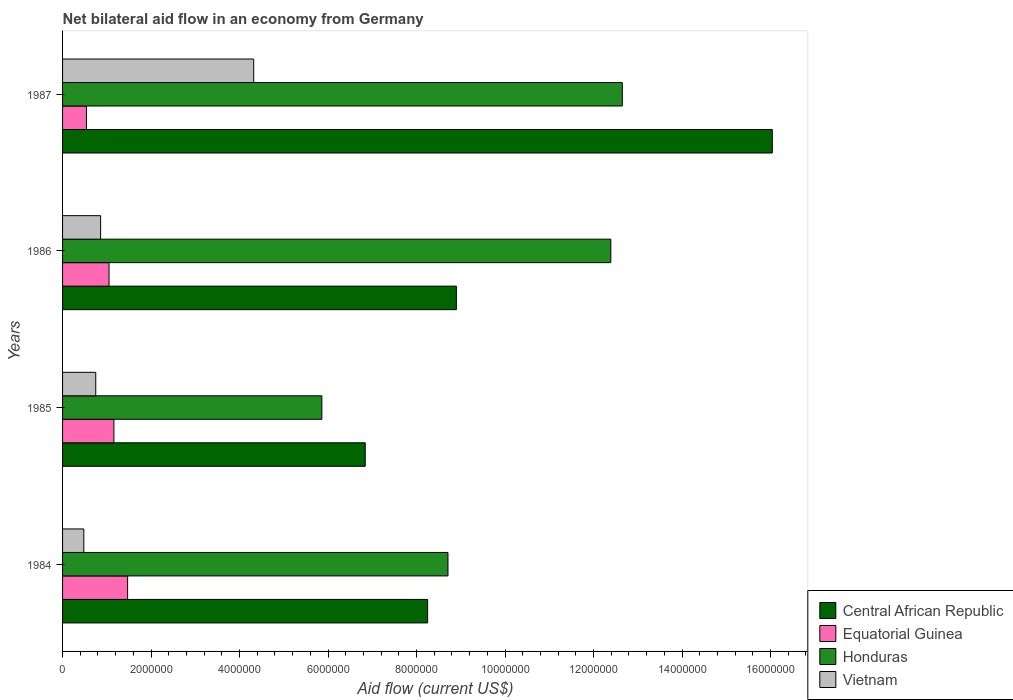How many different coloured bars are there?
Your answer should be very brief. 4. How many bars are there on the 4th tick from the bottom?
Make the answer very short. 4. What is the label of the 3rd group of bars from the top?
Offer a terse response. 1985. In how many cases, is the number of bars for a given year not equal to the number of legend labels?
Keep it short and to the point. 0. What is the net bilateral aid flow in Central African Republic in 1985?
Ensure brevity in your answer.  6.84e+06. Across all years, what is the maximum net bilateral aid flow in Central African Republic?
Offer a very short reply. 1.60e+07. Across all years, what is the minimum net bilateral aid flow in Central African Republic?
Give a very brief answer. 6.84e+06. What is the total net bilateral aid flow in Honduras in the graph?
Offer a terse response. 3.96e+07. What is the difference between the net bilateral aid flow in Central African Republic in 1984 and that in 1987?
Offer a terse response. -7.79e+06. What is the difference between the net bilateral aid flow in Honduras in 1987 and the net bilateral aid flow in Equatorial Guinea in 1986?
Give a very brief answer. 1.16e+07. What is the average net bilateral aid flow in Honduras per year?
Your response must be concise. 9.90e+06. In the year 1986, what is the difference between the net bilateral aid flow in Central African Republic and net bilateral aid flow in Equatorial Guinea?
Your answer should be compact. 7.85e+06. What is the ratio of the net bilateral aid flow in Honduras in 1984 to that in 1987?
Ensure brevity in your answer.  0.69. Is the net bilateral aid flow in Equatorial Guinea in 1985 less than that in 1987?
Provide a short and direct response. No. Is the difference between the net bilateral aid flow in Central African Republic in 1986 and 1987 greater than the difference between the net bilateral aid flow in Equatorial Guinea in 1986 and 1987?
Provide a succinct answer. No. What is the difference between the highest and the second highest net bilateral aid flow in Honduras?
Provide a succinct answer. 2.60e+05. What is the difference between the highest and the lowest net bilateral aid flow in Equatorial Guinea?
Offer a very short reply. 9.30e+05. In how many years, is the net bilateral aid flow in Central African Republic greater than the average net bilateral aid flow in Central African Republic taken over all years?
Make the answer very short. 1. Is the sum of the net bilateral aid flow in Honduras in 1985 and 1987 greater than the maximum net bilateral aid flow in Equatorial Guinea across all years?
Provide a succinct answer. Yes. Is it the case that in every year, the sum of the net bilateral aid flow in Honduras and net bilateral aid flow in Vietnam is greater than the sum of net bilateral aid flow in Equatorial Guinea and net bilateral aid flow in Central African Republic?
Ensure brevity in your answer.  Yes. What does the 1st bar from the top in 1986 represents?
Make the answer very short. Vietnam. What does the 4th bar from the bottom in 1985 represents?
Offer a very short reply. Vietnam. How many bars are there?
Your response must be concise. 16. How many years are there in the graph?
Keep it short and to the point. 4. What is the difference between two consecutive major ticks on the X-axis?
Your answer should be very brief. 2.00e+06. Are the values on the major ticks of X-axis written in scientific E-notation?
Your answer should be very brief. No. Does the graph contain any zero values?
Your answer should be compact. No. Does the graph contain grids?
Keep it short and to the point. No. Where does the legend appear in the graph?
Ensure brevity in your answer.  Bottom right. How many legend labels are there?
Keep it short and to the point. 4. What is the title of the graph?
Make the answer very short. Net bilateral aid flow in an economy from Germany. What is the label or title of the X-axis?
Provide a short and direct response. Aid flow (current US$). What is the label or title of the Y-axis?
Give a very brief answer. Years. What is the Aid flow (current US$) of Central African Republic in 1984?
Offer a very short reply. 8.25e+06. What is the Aid flow (current US$) in Equatorial Guinea in 1984?
Offer a terse response. 1.47e+06. What is the Aid flow (current US$) of Honduras in 1984?
Make the answer very short. 8.71e+06. What is the Aid flow (current US$) in Central African Republic in 1985?
Provide a short and direct response. 6.84e+06. What is the Aid flow (current US$) in Equatorial Guinea in 1985?
Offer a very short reply. 1.16e+06. What is the Aid flow (current US$) of Honduras in 1985?
Your answer should be very brief. 5.86e+06. What is the Aid flow (current US$) in Vietnam in 1985?
Provide a short and direct response. 7.50e+05. What is the Aid flow (current US$) of Central African Republic in 1986?
Provide a short and direct response. 8.90e+06. What is the Aid flow (current US$) of Equatorial Guinea in 1986?
Your answer should be very brief. 1.05e+06. What is the Aid flow (current US$) in Honduras in 1986?
Your answer should be very brief. 1.24e+07. What is the Aid flow (current US$) of Vietnam in 1986?
Your response must be concise. 8.60e+05. What is the Aid flow (current US$) of Central African Republic in 1987?
Make the answer very short. 1.60e+07. What is the Aid flow (current US$) in Equatorial Guinea in 1987?
Offer a very short reply. 5.40e+05. What is the Aid flow (current US$) of Honduras in 1987?
Your answer should be very brief. 1.26e+07. What is the Aid flow (current US$) in Vietnam in 1987?
Your response must be concise. 4.32e+06. Across all years, what is the maximum Aid flow (current US$) of Central African Republic?
Make the answer very short. 1.60e+07. Across all years, what is the maximum Aid flow (current US$) in Equatorial Guinea?
Your response must be concise. 1.47e+06. Across all years, what is the maximum Aid flow (current US$) of Honduras?
Give a very brief answer. 1.26e+07. Across all years, what is the maximum Aid flow (current US$) in Vietnam?
Your answer should be very brief. 4.32e+06. Across all years, what is the minimum Aid flow (current US$) of Central African Republic?
Provide a short and direct response. 6.84e+06. Across all years, what is the minimum Aid flow (current US$) of Equatorial Guinea?
Your answer should be compact. 5.40e+05. Across all years, what is the minimum Aid flow (current US$) in Honduras?
Provide a succinct answer. 5.86e+06. What is the total Aid flow (current US$) in Central African Republic in the graph?
Provide a succinct answer. 4.00e+07. What is the total Aid flow (current US$) of Equatorial Guinea in the graph?
Provide a succinct answer. 4.22e+06. What is the total Aid flow (current US$) in Honduras in the graph?
Your response must be concise. 3.96e+07. What is the total Aid flow (current US$) in Vietnam in the graph?
Your response must be concise. 6.41e+06. What is the difference between the Aid flow (current US$) of Central African Republic in 1984 and that in 1985?
Your answer should be compact. 1.41e+06. What is the difference between the Aid flow (current US$) in Equatorial Guinea in 1984 and that in 1985?
Offer a very short reply. 3.10e+05. What is the difference between the Aid flow (current US$) of Honduras in 1984 and that in 1985?
Keep it short and to the point. 2.85e+06. What is the difference between the Aid flow (current US$) in Central African Republic in 1984 and that in 1986?
Your answer should be very brief. -6.50e+05. What is the difference between the Aid flow (current US$) of Equatorial Guinea in 1984 and that in 1986?
Keep it short and to the point. 4.20e+05. What is the difference between the Aid flow (current US$) in Honduras in 1984 and that in 1986?
Give a very brief answer. -3.68e+06. What is the difference between the Aid flow (current US$) in Vietnam in 1984 and that in 1986?
Provide a succinct answer. -3.80e+05. What is the difference between the Aid flow (current US$) of Central African Republic in 1984 and that in 1987?
Offer a terse response. -7.79e+06. What is the difference between the Aid flow (current US$) of Equatorial Guinea in 1984 and that in 1987?
Keep it short and to the point. 9.30e+05. What is the difference between the Aid flow (current US$) in Honduras in 1984 and that in 1987?
Your answer should be compact. -3.94e+06. What is the difference between the Aid flow (current US$) of Vietnam in 1984 and that in 1987?
Offer a very short reply. -3.84e+06. What is the difference between the Aid flow (current US$) in Central African Republic in 1985 and that in 1986?
Offer a terse response. -2.06e+06. What is the difference between the Aid flow (current US$) in Honduras in 1985 and that in 1986?
Offer a terse response. -6.53e+06. What is the difference between the Aid flow (current US$) of Central African Republic in 1985 and that in 1987?
Ensure brevity in your answer.  -9.20e+06. What is the difference between the Aid flow (current US$) of Equatorial Guinea in 1985 and that in 1987?
Ensure brevity in your answer.  6.20e+05. What is the difference between the Aid flow (current US$) in Honduras in 1985 and that in 1987?
Give a very brief answer. -6.79e+06. What is the difference between the Aid flow (current US$) of Vietnam in 1985 and that in 1987?
Provide a succinct answer. -3.57e+06. What is the difference between the Aid flow (current US$) of Central African Republic in 1986 and that in 1987?
Give a very brief answer. -7.14e+06. What is the difference between the Aid flow (current US$) of Equatorial Guinea in 1986 and that in 1987?
Your answer should be compact. 5.10e+05. What is the difference between the Aid flow (current US$) of Honduras in 1986 and that in 1987?
Make the answer very short. -2.60e+05. What is the difference between the Aid flow (current US$) in Vietnam in 1986 and that in 1987?
Your answer should be compact. -3.46e+06. What is the difference between the Aid flow (current US$) of Central African Republic in 1984 and the Aid flow (current US$) of Equatorial Guinea in 1985?
Ensure brevity in your answer.  7.09e+06. What is the difference between the Aid flow (current US$) in Central African Republic in 1984 and the Aid flow (current US$) in Honduras in 1985?
Provide a succinct answer. 2.39e+06. What is the difference between the Aid flow (current US$) in Central African Republic in 1984 and the Aid flow (current US$) in Vietnam in 1985?
Your response must be concise. 7.50e+06. What is the difference between the Aid flow (current US$) of Equatorial Guinea in 1984 and the Aid flow (current US$) of Honduras in 1985?
Your answer should be compact. -4.39e+06. What is the difference between the Aid flow (current US$) in Equatorial Guinea in 1984 and the Aid flow (current US$) in Vietnam in 1985?
Ensure brevity in your answer.  7.20e+05. What is the difference between the Aid flow (current US$) in Honduras in 1984 and the Aid flow (current US$) in Vietnam in 1985?
Ensure brevity in your answer.  7.96e+06. What is the difference between the Aid flow (current US$) of Central African Republic in 1984 and the Aid flow (current US$) of Equatorial Guinea in 1986?
Offer a terse response. 7.20e+06. What is the difference between the Aid flow (current US$) in Central African Republic in 1984 and the Aid flow (current US$) in Honduras in 1986?
Your response must be concise. -4.14e+06. What is the difference between the Aid flow (current US$) in Central African Republic in 1984 and the Aid flow (current US$) in Vietnam in 1986?
Keep it short and to the point. 7.39e+06. What is the difference between the Aid flow (current US$) in Equatorial Guinea in 1984 and the Aid flow (current US$) in Honduras in 1986?
Your response must be concise. -1.09e+07. What is the difference between the Aid flow (current US$) of Honduras in 1984 and the Aid flow (current US$) of Vietnam in 1986?
Your answer should be very brief. 7.85e+06. What is the difference between the Aid flow (current US$) in Central African Republic in 1984 and the Aid flow (current US$) in Equatorial Guinea in 1987?
Keep it short and to the point. 7.71e+06. What is the difference between the Aid flow (current US$) of Central African Republic in 1984 and the Aid flow (current US$) of Honduras in 1987?
Provide a succinct answer. -4.40e+06. What is the difference between the Aid flow (current US$) in Central African Republic in 1984 and the Aid flow (current US$) in Vietnam in 1987?
Give a very brief answer. 3.93e+06. What is the difference between the Aid flow (current US$) in Equatorial Guinea in 1984 and the Aid flow (current US$) in Honduras in 1987?
Offer a very short reply. -1.12e+07. What is the difference between the Aid flow (current US$) in Equatorial Guinea in 1984 and the Aid flow (current US$) in Vietnam in 1987?
Make the answer very short. -2.85e+06. What is the difference between the Aid flow (current US$) in Honduras in 1984 and the Aid flow (current US$) in Vietnam in 1987?
Your response must be concise. 4.39e+06. What is the difference between the Aid flow (current US$) of Central African Republic in 1985 and the Aid flow (current US$) of Equatorial Guinea in 1986?
Your answer should be compact. 5.79e+06. What is the difference between the Aid flow (current US$) of Central African Republic in 1985 and the Aid flow (current US$) of Honduras in 1986?
Ensure brevity in your answer.  -5.55e+06. What is the difference between the Aid flow (current US$) in Central African Republic in 1985 and the Aid flow (current US$) in Vietnam in 1986?
Provide a short and direct response. 5.98e+06. What is the difference between the Aid flow (current US$) in Equatorial Guinea in 1985 and the Aid flow (current US$) in Honduras in 1986?
Provide a short and direct response. -1.12e+07. What is the difference between the Aid flow (current US$) of Equatorial Guinea in 1985 and the Aid flow (current US$) of Vietnam in 1986?
Your answer should be very brief. 3.00e+05. What is the difference between the Aid flow (current US$) of Honduras in 1985 and the Aid flow (current US$) of Vietnam in 1986?
Give a very brief answer. 5.00e+06. What is the difference between the Aid flow (current US$) in Central African Republic in 1985 and the Aid flow (current US$) in Equatorial Guinea in 1987?
Provide a succinct answer. 6.30e+06. What is the difference between the Aid flow (current US$) of Central African Republic in 1985 and the Aid flow (current US$) of Honduras in 1987?
Offer a terse response. -5.81e+06. What is the difference between the Aid flow (current US$) of Central African Republic in 1985 and the Aid flow (current US$) of Vietnam in 1987?
Offer a very short reply. 2.52e+06. What is the difference between the Aid flow (current US$) in Equatorial Guinea in 1985 and the Aid flow (current US$) in Honduras in 1987?
Make the answer very short. -1.15e+07. What is the difference between the Aid flow (current US$) of Equatorial Guinea in 1985 and the Aid flow (current US$) of Vietnam in 1987?
Your response must be concise. -3.16e+06. What is the difference between the Aid flow (current US$) in Honduras in 1985 and the Aid flow (current US$) in Vietnam in 1987?
Make the answer very short. 1.54e+06. What is the difference between the Aid flow (current US$) in Central African Republic in 1986 and the Aid flow (current US$) in Equatorial Guinea in 1987?
Keep it short and to the point. 8.36e+06. What is the difference between the Aid flow (current US$) of Central African Republic in 1986 and the Aid flow (current US$) of Honduras in 1987?
Your response must be concise. -3.75e+06. What is the difference between the Aid flow (current US$) of Central African Republic in 1986 and the Aid flow (current US$) of Vietnam in 1987?
Ensure brevity in your answer.  4.58e+06. What is the difference between the Aid flow (current US$) in Equatorial Guinea in 1986 and the Aid flow (current US$) in Honduras in 1987?
Your response must be concise. -1.16e+07. What is the difference between the Aid flow (current US$) of Equatorial Guinea in 1986 and the Aid flow (current US$) of Vietnam in 1987?
Offer a terse response. -3.27e+06. What is the difference between the Aid flow (current US$) of Honduras in 1986 and the Aid flow (current US$) of Vietnam in 1987?
Ensure brevity in your answer.  8.07e+06. What is the average Aid flow (current US$) in Central African Republic per year?
Ensure brevity in your answer.  1.00e+07. What is the average Aid flow (current US$) in Equatorial Guinea per year?
Your response must be concise. 1.06e+06. What is the average Aid flow (current US$) in Honduras per year?
Give a very brief answer. 9.90e+06. What is the average Aid flow (current US$) in Vietnam per year?
Ensure brevity in your answer.  1.60e+06. In the year 1984, what is the difference between the Aid flow (current US$) of Central African Republic and Aid flow (current US$) of Equatorial Guinea?
Ensure brevity in your answer.  6.78e+06. In the year 1984, what is the difference between the Aid flow (current US$) of Central African Republic and Aid flow (current US$) of Honduras?
Your answer should be very brief. -4.60e+05. In the year 1984, what is the difference between the Aid flow (current US$) of Central African Republic and Aid flow (current US$) of Vietnam?
Keep it short and to the point. 7.77e+06. In the year 1984, what is the difference between the Aid flow (current US$) in Equatorial Guinea and Aid flow (current US$) in Honduras?
Your answer should be compact. -7.24e+06. In the year 1984, what is the difference between the Aid flow (current US$) in Equatorial Guinea and Aid flow (current US$) in Vietnam?
Offer a very short reply. 9.90e+05. In the year 1984, what is the difference between the Aid flow (current US$) of Honduras and Aid flow (current US$) of Vietnam?
Your response must be concise. 8.23e+06. In the year 1985, what is the difference between the Aid flow (current US$) of Central African Republic and Aid flow (current US$) of Equatorial Guinea?
Offer a terse response. 5.68e+06. In the year 1985, what is the difference between the Aid flow (current US$) in Central African Republic and Aid flow (current US$) in Honduras?
Offer a very short reply. 9.80e+05. In the year 1985, what is the difference between the Aid flow (current US$) of Central African Republic and Aid flow (current US$) of Vietnam?
Provide a succinct answer. 6.09e+06. In the year 1985, what is the difference between the Aid flow (current US$) of Equatorial Guinea and Aid flow (current US$) of Honduras?
Provide a short and direct response. -4.70e+06. In the year 1985, what is the difference between the Aid flow (current US$) in Equatorial Guinea and Aid flow (current US$) in Vietnam?
Provide a succinct answer. 4.10e+05. In the year 1985, what is the difference between the Aid flow (current US$) in Honduras and Aid flow (current US$) in Vietnam?
Keep it short and to the point. 5.11e+06. In the year 1986, what is the difference between the Aid flow (current US$) of Central African Republic and Aid flow (current US$) of Equatorial Guinea?
Provide a short and direct response. 7.85e+06. In the year 1986, what is the difference between the Aid flow (current US$) in Central African Republic and Aid flow (current US$) in Honduras?
Your response must be concise. -3.49e+06. In the year 1986, what is the difference between the Aid flow (current US$) in Central African Republic and Aid flow (current US$) in Vietnam?
Offer a very short reply. 8.04e+06. In the year 1986, what is the difference between the Aid flow (current US$) of Equatorial Guinea and Aid flow (current US$) of Honduras?
Offer a very short reply. -1.13e+07. In the year 1986, what is the difference between the Aid flow (current US$) of Equatorial Guinea and Aid flow (current US$) of Vietnam?
Give a very brief answer. 1.90e+05. In the year 1986, what is the difference between the Aid flow (current US$) of Honduras and Aid flow (current US$) of Vietnam?
Your response must be concise. 1.15e+07. In the year 1987, what is the difference between the Aid flow (current US$) of Central African Republic and Aid flow (current US$) of Equatorial Guinea?
Your answer should be compact. 1.55e+07. In the year 1987, what is the difference between the Aid flow (current US$) in Central African Republic and Aid flow (current US$) in Honduras?
Offer a very short reply. 3.39e+06. In the year 1987, what is the difference between the Aid flow (current US$) of Central African Republic and Aid flow (current US$) of Vietnam?
Your response must be concise. 1.17e+07. In the year 1987, what is the difference between the Aid flow (current US$) in Equatorial Guinea and Aid flow (current US$) in Honduras?
Provide a short and direct response. -1.21e+07. In the year 1987, what is the difference between the Aid flow (current US$) of Equatorial Guinea and Aid flow (current US$) of Vietnam?
Your response must be concise. -3.78e+06. In the year 1987, what is the difference between the Aid flow (current US$) in Honduras and Aid flow (current US$) in Vietnam?
Give a very brief answer. 8.33e+06. What is the ratio of the Aid flow (current US$) of Central African Republic in 1984 to that in 1985?
Make the answer very short. 1.21. What is the ratio of the Aid flow (current US$) in Equatorial Guinea in 1984 to that in 1985?
Provide a short and direct response. 1.27. What is the ratio of the Aid flow (current US$) of Honduras in 1984 to that in 1985?
Provide a short and direct response. 1.49. What is the ratio of the Aid flow (current US$) of Vietnam in 1984 to that in 1985?
Provide a succinct answer. 0.64. What is the ratio of the Aid flow (current US$) of Central African Republic in 1984 to that in 1986?
Offer a terse response. 0.93. What is the ratio of the Aid flow (current US$) in Equatorial Guinea in 1984 to that in 1986?
Your answer should be compact. 1.4. What is the ratio of the Aid flow (current US$) in Honduras in 1984 to that in 1986?
Provide a succinct answer. 0.7. What is the ratio of the Aid flow (current US$) of Vietnam in 1984 to that in 1986?
Your answer should be very brief. 0.56. What is the ratio of the Aid flow (current US$) in Central African Republic in 1984 to that in 1987?
Make the answer very short. 0.51. What is the ratio of the Aid flow (current US$) of Equatorial Guinea in 1984 to that in 1987?
Your response must be concise. 2.72. What is the ratio of the Aid flow (current US$) of Honduras in 1984 to that in 1987?
Your answer should be compact. 0.69. What is the ratio of the Aid flow (current US$) of Central African Republic in 1985 to that in 1986?
Offer a very short reply. 0.77. What is the ratio of the Aid flow (current US$) of Equatorial Guinea in 1985 to that in 1986?
Ensure brevity in your answer.  1.1. What is the ratio of the Aid flow (current US$) of Honduras in 1985 to that in 1986?
Offer a very short reply. 0.47. What is the ratio of the Aid flow (current US$) of Vietnam in 1985 to that in 1986?
Give a very brief answer. 0.87. What is the ratio of the Aid flow (current US$) in Central African Republic in 1985 to that in 1987?
Ensure brevity in your answer.  0.43. What is the ratio of the Aid flow (current US$) of Equatorial Guinea in 1985 to that in 1987?
Provide a short and direct response. 2.15. What is the ratio of the Aid flow (current US$) of Honduras in 1985 to that in 1987?
Keep it short and to the point. 0.46. What is the ratio of the Aid flow (current US$) in Vietnam in 1985 to that in 1987?
Your answer should be very brief. 0.17. What is the ratio of the Aid flow (current US$) of Central African Republic in 1986 to that in 1987?
Your answer should be very brief. 0.55. What is the ratio of the Aid flow (current US$) in Equatorial Guinea in 1986 to that in 1987?
Provide a short and direct response. 1.94. What is the ratio of the Aid flow (current US$) in Honduras in 1986 to that in 1987?
Ensure brevity in your answer.  0.98. What is the ratio of the Aid flow (current US$) in Vietnam in 1986 to that in 1987?
Offer a very short reply. 0.2. What is the difference between the highest and the second highest Aid flow (current US$) of Central African Republic?
Offer a terse response. 7.14e+06. What is the difference between the highest and the second highest Aid flow (current US$) of Equatorial Guinea?
Your response must be concise. 3.10e+05. What is the difference between the highest and the second highest Aid flow (current US$) in Vietnam?
Your answer should be very brief. 3.46e+06. What is the difference between the highest and the lowest Aid flow (current US$) of Central African Republic?
Ensure brevity in your answer.  9.20e+06. What is the difference between the highest and the lowest Aid flow (current US$) of Equatorial Guinea?
Give a very brief answer. 9.30e+05. What is the difference between the highest and the lowest Aid flow (current US$) in Honduras?
Ensure brevity in your answer.  6.79e+06. What is the difference between the highest and the lowest Aid flow (current US$) in Vietnam?
Provide a short and direct response. 3.84e+06. 